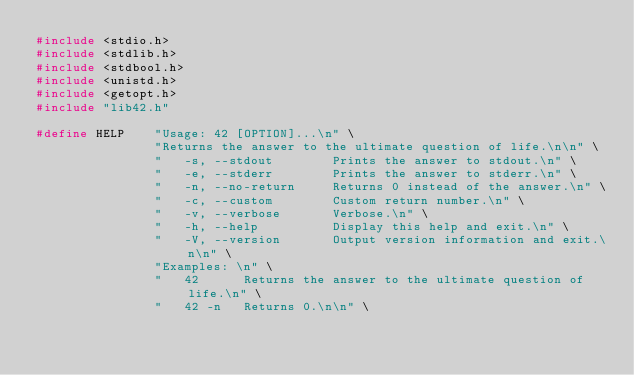<code> <loc_0><loc_0><loc_500><loc_500><_C_>#include <stdio.h>
#include <stdlib.h>
#include <stdbool.h>
#include <unistd.h>
#include <getopt.h>
#include "lib42.h"

#define HELP    "Usage: 42 [OPTION]...\n" \
                "Returns the answer to the ultimate question of life.\n\n" \
                "   -s, --stdout        Prints the answer to stdout.\n" \
                "   -e, --stderr        Prints the answer to stderr.\n" \
                "   -n, --no-return     Returns 0 instead of the answer.\n" \
                "   -c, --custom        Custom return number.\n" \
                "   -v, --verbose       Verbose.\n" \
                "   -h, --help          Display this help and exit.\n" \
                "   -V, --version       Output version information and exit.\n\n" \
                "Examples: \n" \
                "   42      Returns the answer to the ultimate question of life.\n" \
                "   42 -n   Returns 0.\n\n" \</code> 